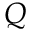<formula> <loc_0><loc_0><loc_500><loc_500>Q</formula> 